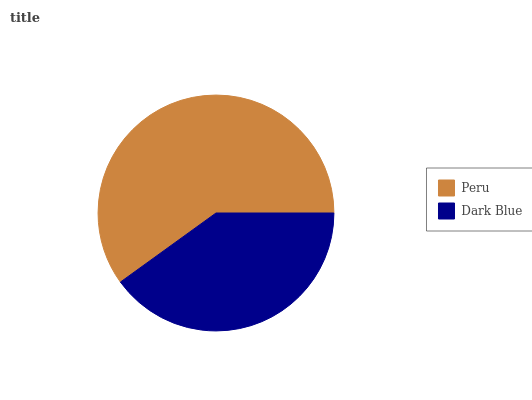Is Dark Blue the minimum?
Answer yes or no. Yes. Is Peru the maximum?
Answer yes or no. Yes. Is Dark Blue the maximum?
Answer yes or no. No. Is Peru greater than Dark Blue?
Answer yes or no. Yes. Is Dark Blue less than Peru?
Answer yes or no. Yes. Is Dark Blue greater than Peru?
Answer yes or no. No. Is Peru less than Dark Blue?
Answer yes or no. No. Is Peru the high median?
Answer yes or no. Yes. Is Dark Blue the low median?
Answer yes or no. Yes. Is Dark Blue the high median?
Answer yes or no. No. Is Peru the low median?
Answer yes or no. No. 